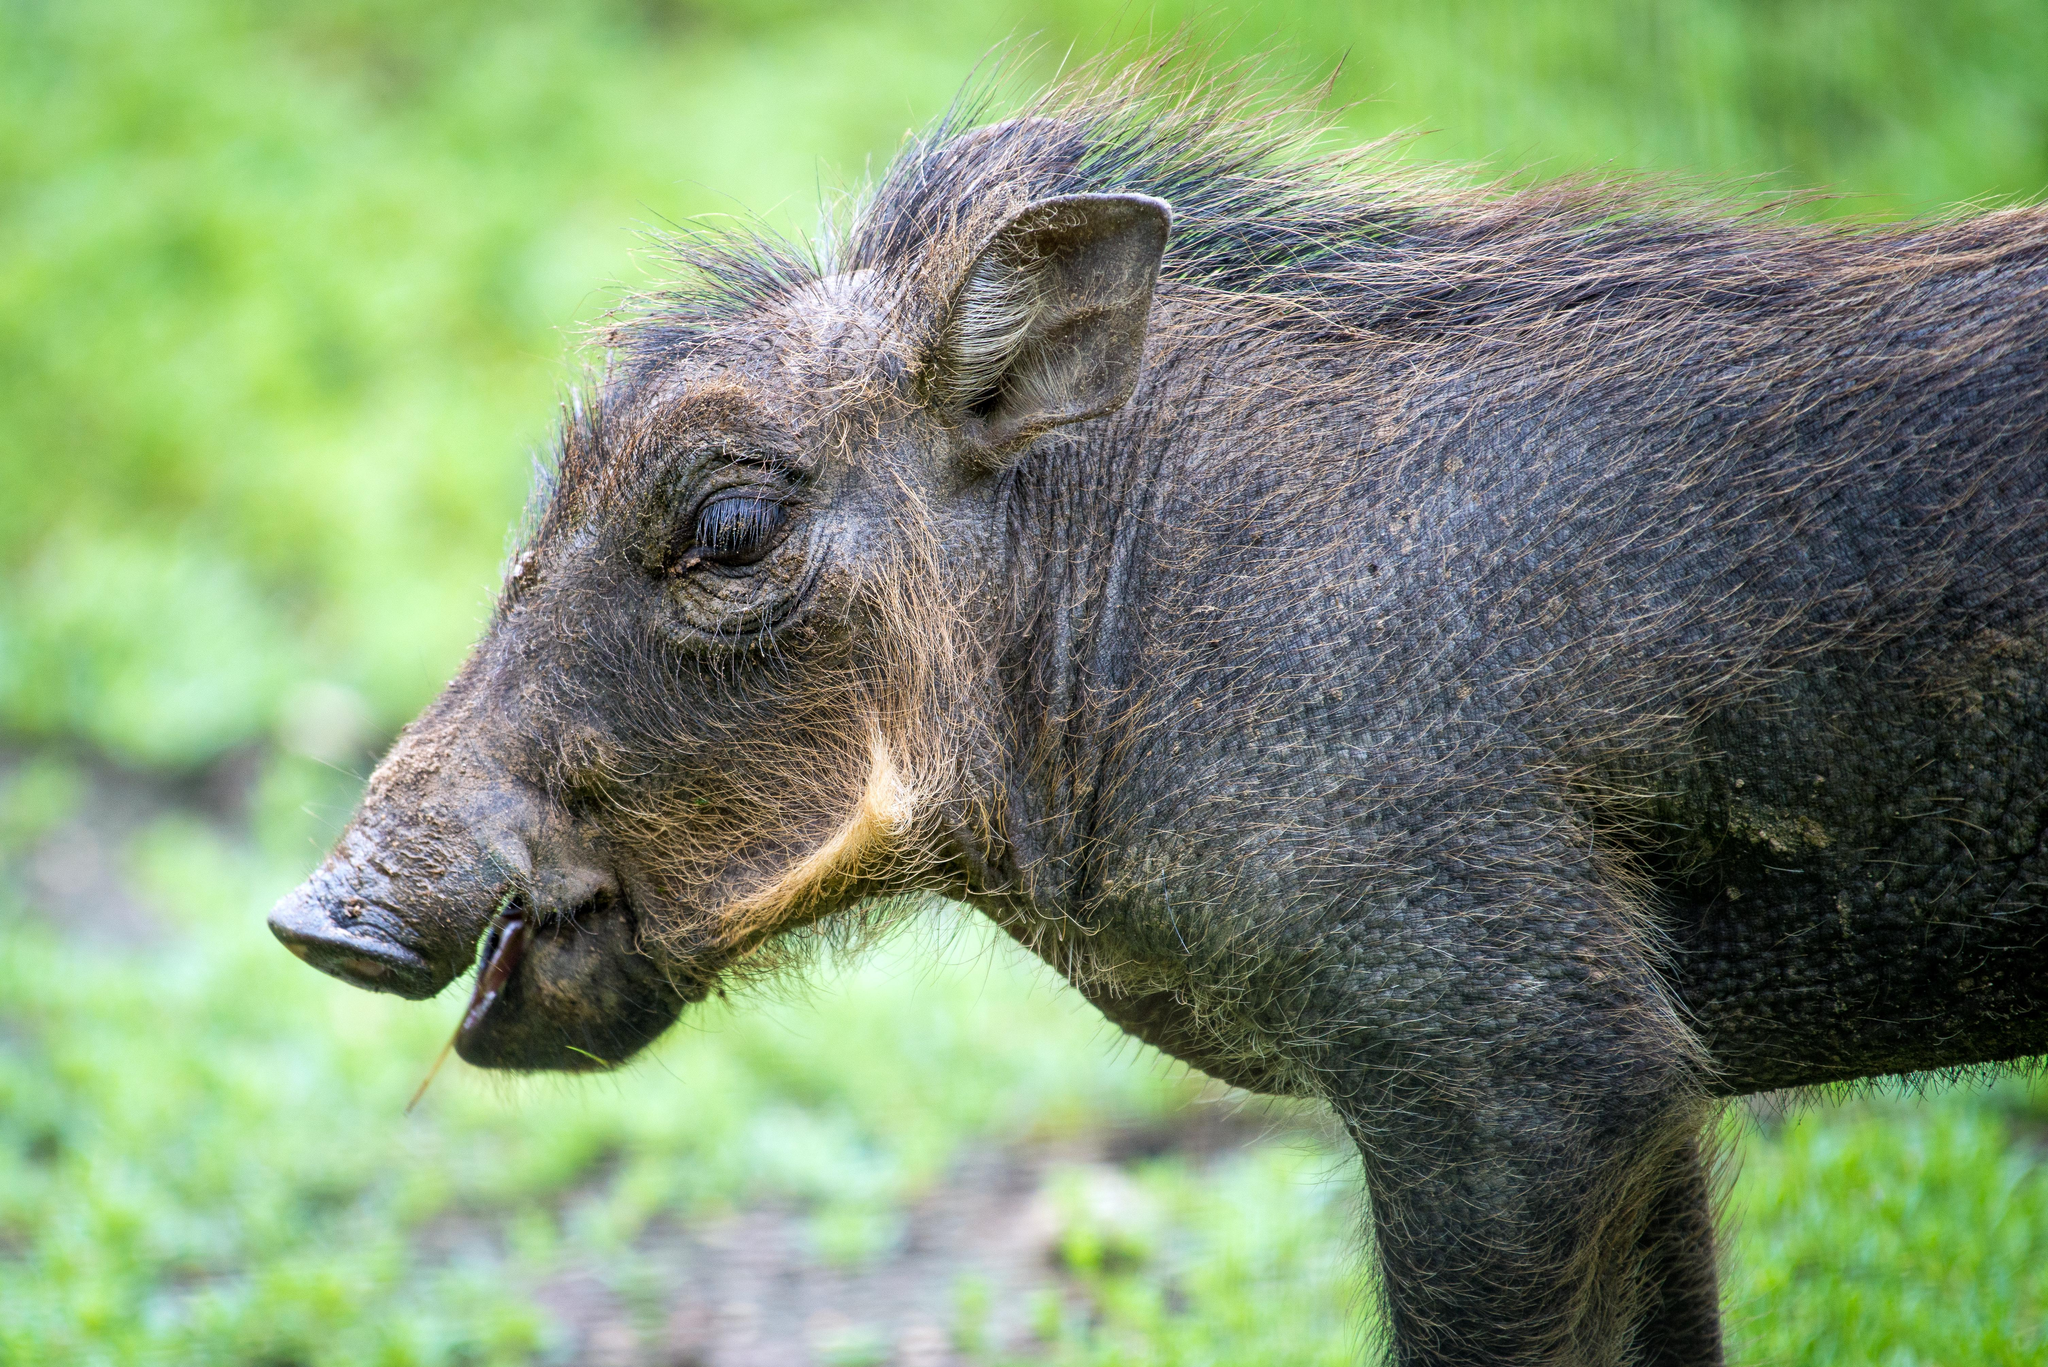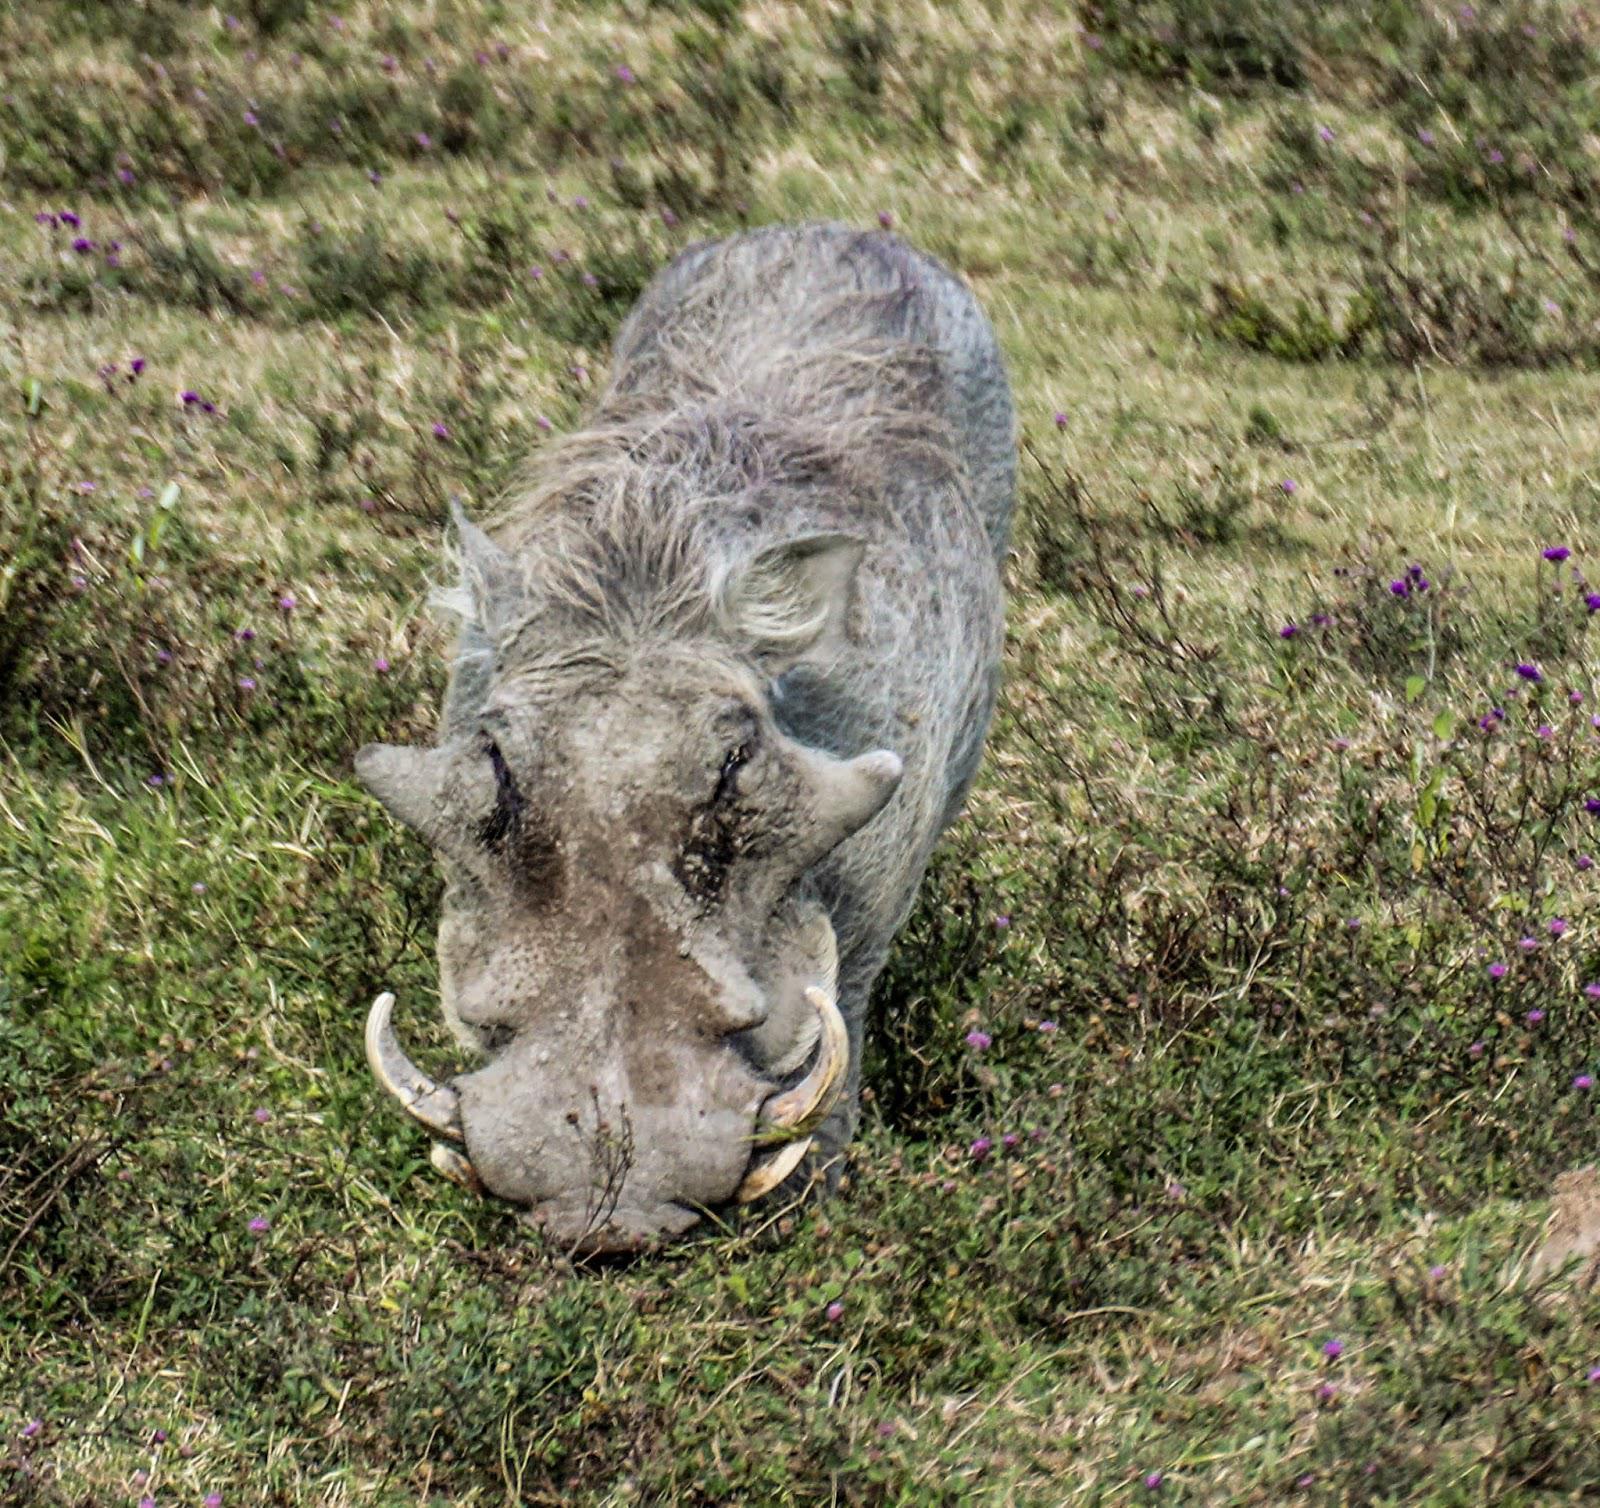The first image is the image on the left, the second image is the image on the right. Assess this claim about the two images: "The only animals shown are exactly two warthogs, in total.". Correct or not? Answer yes or no. Yes. 